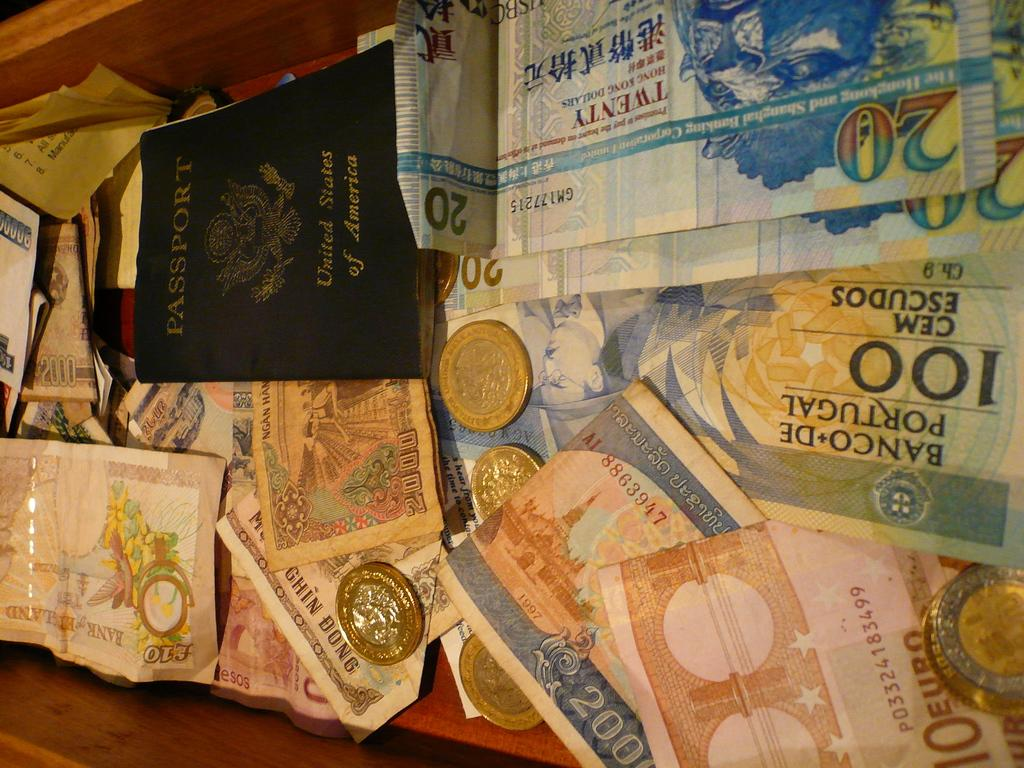<image>
Relay a brief, clear account of the picture shown. A pile of bank notes and coins that say Banco de Portugal. 